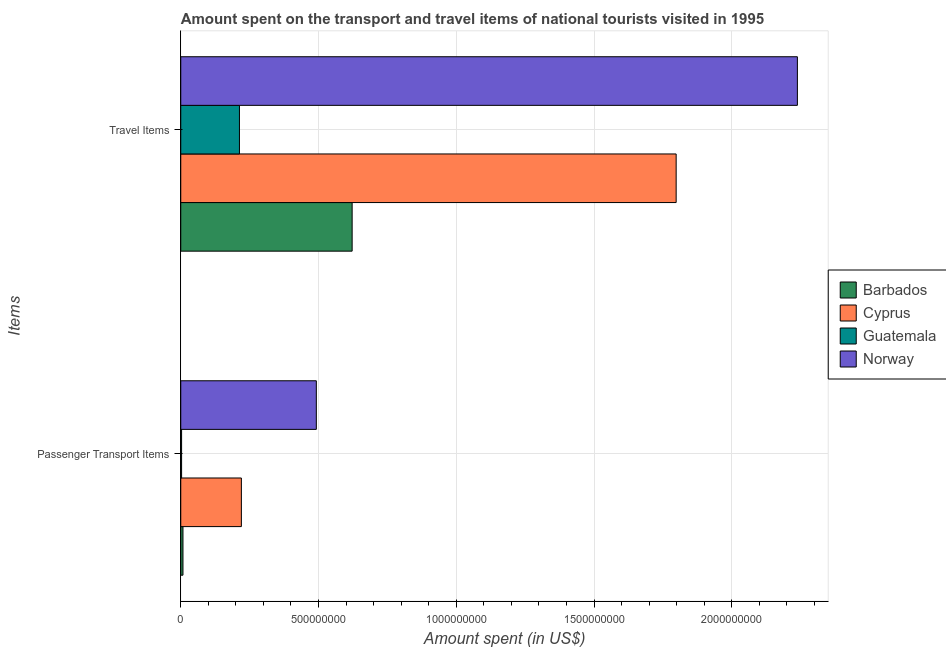How many groups of bars are there?
Keep it short and to the point. 2. How many bars are there on the 1st tick from the bottom?
Keep it short and to the point. 4. What is the label of the 2nd group of bars from the top?
Offer a terse response. Passenger Transport Items. What is the amount spent on passenger transport items in Barbados?
Make the answer very short. 8.00e+06. Across all countries, what is the maximum amount spent in travel items?
Your answer should be very brief. 2.24e+09. Across all countries, what is the minimum amount spent in travel items?
Provide a succinct answer. 2.13e+08. In which country was the amount spent in travel items maximum?
Your response must be concise. Norway. In which country was the amount spent in travel items minimum?
Your response must be concise. Guatemala. What is the total amount spent on passenger transport items in the graph?
Make the answer very short. 7.23e+08. What is the difference between the amount spent on passenger transport items in Norway and that in Guatemala?
Keep it short and to the point. 4.89e+08. What is the difference between the amount spent on passenger transport items in Barbados and the amount spent in travel items in Guatemala?
Give a very brief answer. -2.05e+08. What is the average amount spent in travel items per country?
Provide a short and direct response. 1.22e+09. What is the difference between the amount spent on passenger transport items and amount spent in travel items in Norway?
Keep it short and to the point. -1.75e+09. What is the ratio of the amount spent on passenger transport items in Barbados to that in Norway?
Provide a succinct answer. 0.02. What does the 2nd bar from the bottom in Passenger Transport Items represents?
Ensure brevity in your answer.  Cyprus. Are all the bars in the graph horizontal?
Your answer should be very brief. Yes. What is the difference between two consecutive major ticks on the X-axis?
Your response must be concise. 5.00e+08. Are the values on the major ticks of X-axis written in scientific E-notation?
Keep it short and to the point. No. Does the graph contain any zero values?
Your answer should be compact. No. Does the graph contain grids?
Offer a terse response. Yes. Where does the legend appear in the graph?
Your answer should be compact. Center right. How many legend labels are there?
Your response must be concise. 4. What is the title of the graph?
Provide a succinct answer. Amount spent on the transport and travel items of national tourists visited in 1995. Does "France" appear as one of the legend labels in the graph?
Keep it short and to the point. No. What is the label or title of the X-axis?
Ensure brevity in your answer.  Amount spent (in US$). What is the label or title of the Y-axis?
Give a very brief answer. Items. What is the Amount spent (in US$) in Cyprus in Passenger Transport Items?
Your response must be concise. 2.20e+08. What is the Amount spent (in US$) in Norway in Passenger Transport Items?
Provide a short and direct response. 4.92e+08. What is the Amount spent (in US$) of Barbados in Travel Items?
Ensure brevity in your answer.  6.22e+08. What is the Amount spent (in US$) in Cyprus in Travel Items?
Make the answer very short. 1.80e+09. What is the Amount spent (in US$) of Guatemala in Travel Items?
Offer a terse response. 2.13e+08. What is the Amount spent (in US$) in Norway in Travel Items?
Provide a short and direct response. 2.24e+09. Across all Items, what is the maximum Amount spent (in US$) of Barbados?
Your response must be concise. 6.22e+08. Across all Items, what is the maximum Amount spent (in US$) of Cyprus?
Give a very brief answer. 1.80e+09. Across all Items, what is the maximum Amount spent (in US$) in Guatemala?
Provide a short and direct response. 2.13e+08. Across all Items, what is the maximum Amount spent (in US$) of Norway?
Make the answer very short. 2.24e+09. Across all Items, what is the minimum Amount spent (in US$) of Cyprus?
Give a very brief answer. 2.20e+08. Across all Items, what is the minimum Amount spent (in US$) in Norway?
Your answer should be very brief. 4.92e+08. What is the total Amount spent (in US$) of Barbados in the graph?
Provide a succinct answer. 6.30e+08. What is the total Amount spent (in US$) of Cyprus in the graph?
Provide a succinct answer. 2.02e+09. What is the total Amount spent (in US$) of Guatemala in the graph?
Offer a very short reply. 2.16e+08. What is the total Amount spent (in US$) of Norway in the graph?
Make the answer very short. 2.73e+09. What is the difference between the Amount spent (in US$) in Barbados in Passenger Transport Items and that in Travel Items?
Provide a succinct answer. -6.14e+08. What is the difference between the Amount spent (in US$) of Cyprus in Passenger Transport Items and that in Travel Items?
Keep it short and to the point. -1.58e+09. What is the difference between the Amount spent (in US$) of Guatemala in Passenger Transport Items and that in Travel Items?
Offer a very short reply. -2.10e+08. What is the difference between the Amount spent (in US$) in Norway in Passenger Transport Items and that in Travel Items?
Your response must be concise. -1.75e+09. What is the difference between the Amount spent (in US$) in Barbados in Passenger Transport Items and the Amount spent (in US$) in Cyprus in Travel Items?
Offer a terse response. -1.79e+09. What is the difference between the Amount spent (in US$) of Barbados in Passenger Transport Items and the Amount spent (in US$) of Guatemala in Travel Items?
Provide a succinct answer. -2.05e+08. What is the difference between the Amount spent (in US$) of Barbados in Passenger Transport Items and the Amount spent (in US$) of Norway in Travel Items?
Provide a short and direct response. -2.23e+09. What is the difference between the Amount spent (in US$) of Cyprus in Passenger Transport Items and the Amount spent (in US$) of Norway in Travel Items?
Offer a terse response. -2.02e+09. What is the difference between the Amount spent (in US$) in Guatemala in Passenger Transport Items and the Amount spent (in US$) in Norway in Travel Items?
Offer a very short reply. -2.24e+09. What is the average Amount spent (in US$) of Barbados per Items?
Your answer should be very brief. 3.15e+08. What is the average Amount spent (in US$) in Cyprus per Items?
Offer a very short reply. 1.01e+09. What is the average Amount spent (in US$) in Guatemala per Items?
Provide a short and direct response. 1.08e+08. What is the average Amount spent (in US$) in Norway per Items?
Offer a very short reply. 1.36e+09. What is the difference between the Amount spent (in US$) in Barbados and Amount spent (in US$) in Cyprus in Passenger Transport Items?
Provide a succinct answer. -2.12e+08. What is the difference between the Amount spent (in US$) of Barbados and Amount spent (in US$) of Norway in Passenger Transport Items?
Provide a short and direct response. -4.84e+08. What is the difference between the Amount spent (in US$) of Cyprus and Amount spent (in US$) of Guatemala in Passenger Transport Items?
Your response must be concise. 2.17e+08. What is the difference between the Amount spent (in US$) in Cyprus and Amount spent (in US$) in Norway in Passenger Transport Items?
Your response must be concise. -2.72e+08. What is the difference between the Amount spent (in US$) of Guatemala and Amount spent (in US$) of Norway in Passenger Transport Items?
Give a very brief answer. -4.89e+08. What is the difference between the Amount spent (in US$) of Barbados and Amount spent (in US$) of Cyprus in Travel Items?
Ensure brevity in your answer.  -1.18e+09. What is the difference between the Amount spent (in US$) of Barbados and Amount spent (in US$) of Guatemala in Travel Items?
Your answer should be compact. 4.09e+08. What is the difference between the Amount spent (in US$) of Barbados and Amount spent (in US$) of Norway in Travel Items?
Ensure brevity in your answer.  -1.62e+09. What is the difference between the Amount spent (in US$) in Cyprus and Amount spent (in US$) in Guatemala in Travel Items?
Your answer should be compact. 1.58e+09. What is the difference between the Amount spent (in US$) of Cyprus and Amount spent (in US$) of Norway in Travel Items?
Offer a very short reply. -4.40e+08. What is the difference between the Amount spent (in US$) in Guatemala and Amount spent (in US$) in Norway in Travel Items?
Provide a short and direct response. -2.02e+09. What is the ratio of the Amount spent (in US$) of Barbados in Passenger Transport Items to that in Travel Items?
Offer a very short reply. 0.01. What is the ratio of the Amount spent (in US$) of Cyprus in Passenger Transport Items to that in Travel Items?
Offer a terse response. 0.12. What is the ratio of the Amount spent (in US$) in Guatemala in Passenger Transport Items to that in Travel Items?
Keep it short and to the point. 0.01. What is the ratio of the Amount spent (in US$) of Norway in Passenger Transport Items to that in Travel Items?
Keep it short and to the point. 0.22. What is the difference between the highest and the second highest Amount spent (in US$) of Barbados?
Provide a short and direct response. 6.14e+08. What is the difference between the highest and the second highest Amount spent (in US$) of Cyprus?
Offer a terse response. 1.58e+09. What is the difference between the highest and the second highest Amount spent (in US$) of Guatemala?
Your response must be concise. 2.10e+08. What is the difference between the highest and the second highest Amount spent (in US$) of Norway?
Your answer should be very brief. 1.75e+09. What is the difference between the highest and the lowest Amount spent (in US$) in Barbados?
Your response must be concise. 6.14e+08. What is the difference between the highest and the lowest Amount spent (in US$) in Cyprus?
Ensure brevity in your answer.  1.58e+09. What is the difference between the highest and the lowest Amount spent (in US$) in Guatemala?
Offer a very short reply. 2.10e+08. What is the difference between the highest and the lowest Amount spent (in US$) in Norway?
Provide a short and direct response. 1.75e+09. 